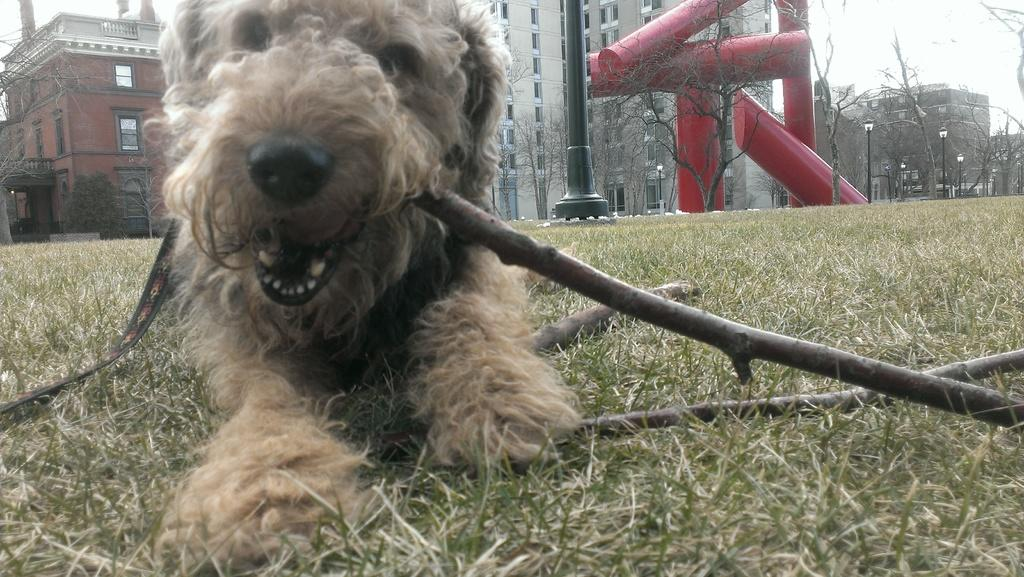What is the dog doing in the image? The dog is lying on the grass and twigs in the image. What can be seen in the background of the image? There are buildings, trees, street poles, street lights, and slides in the background of the image. What part of the natural environment is visible in the image? The sky is visible in the background of the image. What type of scarecrow is standing next to the dog in the image? There is no scarecrow present in the image; it features a dog lying on the grass and twigs. How does the son of the dog feel about the situation in the image? There is no mention of a son or any emotions in the image; it only shows a dog lying on the grass and twigs with a background containing various elements. 